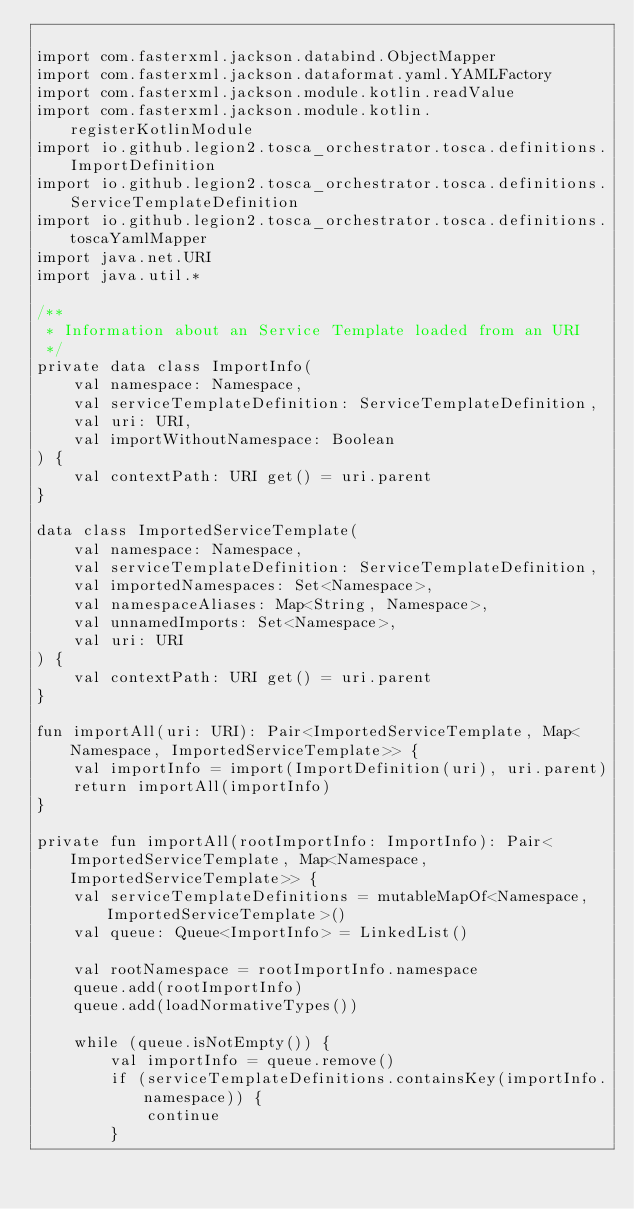Convert code to text. <code><loc_0><loc_0><loc_500><loc_500><_Kotlin_>
import com.fasterxml.jackson.databind.ObjectMapper
import com.fasterxml.jackson.dataformat.yaml.YAMLFactory
import com.fasterxml.jackson.module.kotlin.readValue
import com.fasterxml.jackson.module.kotlin.registerKotlinModule
import io.github.legion2.tosca_orchestrator.tosca.definitions.ImportDefinition
import io.github.legion2.tosca_orchestrator.tosca.definitions.ServiceTemplateDefinition
import io.github.legion2.tosca_orchestrator.tosca.definitions.toscaYamlMapper
import java.net.URI
import java.util.*

/**
 * Information about an Service Template loaded from an URI
 */
private data class ImportInfo(
    val namespace: Namespace,
    val serviceTemplateDefinition: ServiceTemplateDefinition,
    val uri: URI,
    val importWithoutNamespace: Boolean
) {
    val contextPath: URI get() = uri.parent
}

data class ImportedServiceTemplate(
    val namespace: Namespace,
    val serviceTemplateDefinition: ServiceTemplateDefinition,
    val importedNamespaces: Set<Namespace>,
    val namespaceAliases: Map<String, Namespace>,
    val unnamedImports: Set<Namespace>,
    val uri: URI
) {
    val contextPath: URI get() = uri.parent
}

fun importAll(uri: URI): Pair<ImportedServiceTemplate, Map<Namespace, ImportedServiceTemplate>> {
    val importInfo = import(ImportDefinition(uri), uri.parent)
    return importAll(importInfo)
}

private fun importAll(rootImportInfo: ImportInfo): Pair<ImportedServiceTemplate, Map<Namespace, ImportedServiceTemplate>> {
    val serviceTemplateDefinitions = mutableMapOf<Namespace, ImportedServiceTemplate>()
    val queue: Queue<ImportInfo> = LinkedList()

    val rootNamespace = rootImportInfo.namespace
    queue.add(rootImportInfo)
    queue.add(loadNormativeTypes())

    while (queue.isNotEmpty()) {
        val importInfo = queue.remove()
        if (serviceTemplateDefinitions.containsKey(importInfo.namespace)) {
            continue
        }</code> 